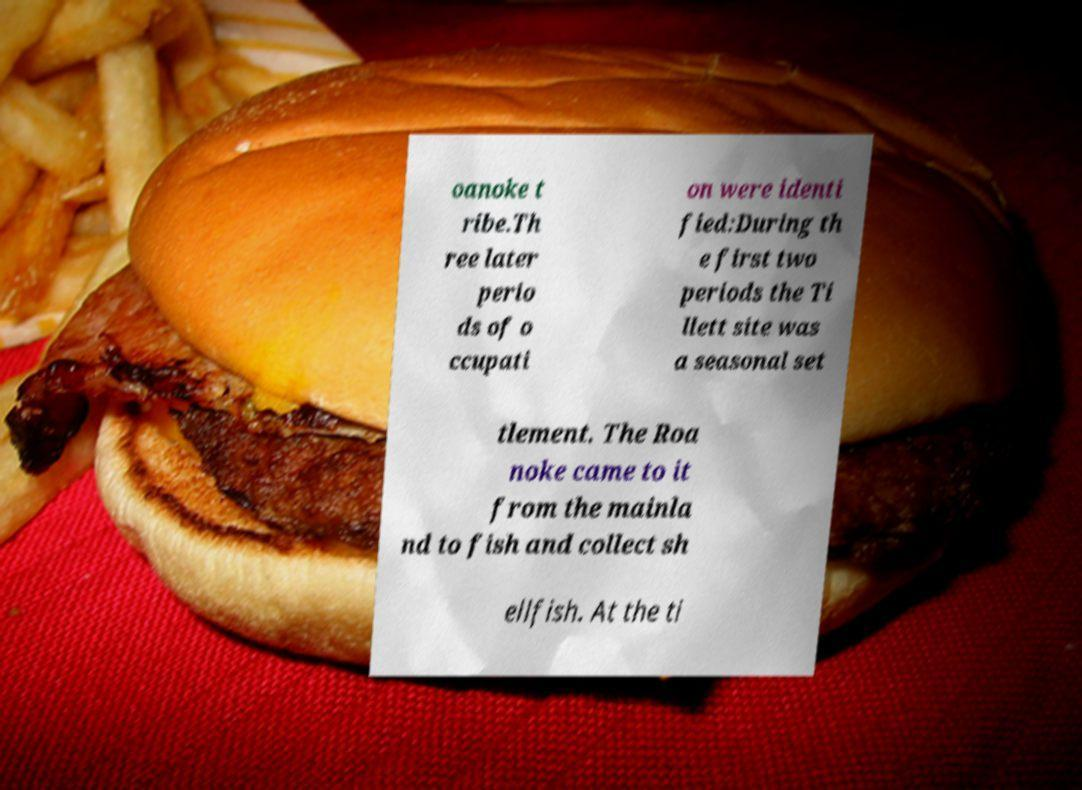Could you assist in decoding the text presented in this image and type it out clearly? oanoke t ribe.Th ree later perio ds of o ccupati on were identi fied:During th e first two periods the Ti llett site was a seasonal set tlement. The Roa noke came to it from the mainla nd to fish and collect sh ellfish. At the ti 